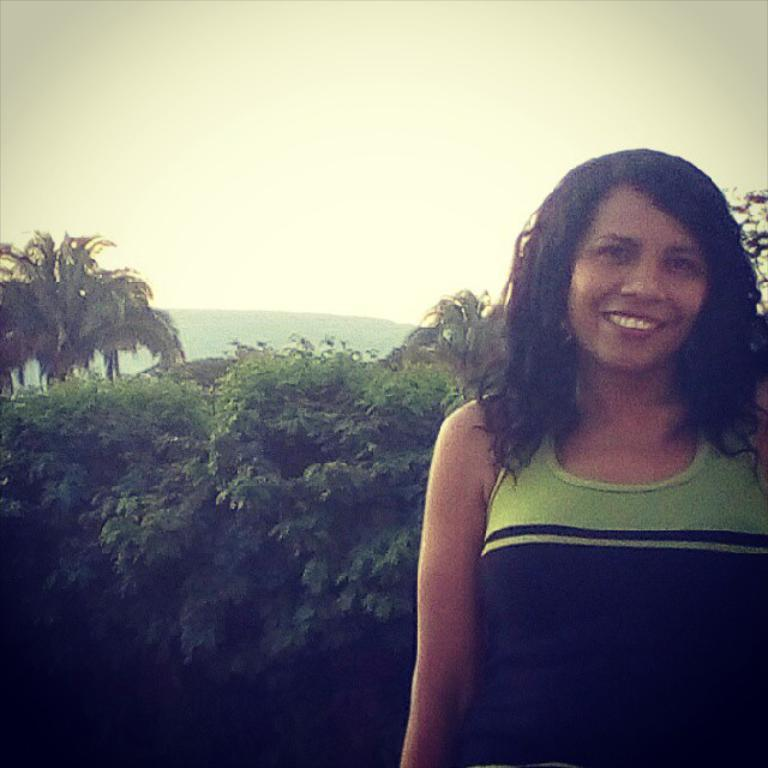Who is the main subject in the foreground of the image? There is a lady in the foreground of the image. What can be seen in the background of the image? There are plants, trees, mountains, and the sky visible in the background of the image. What type of nail is being used to create a rhythm in the image? There is no nail or rhythm present in the image. 